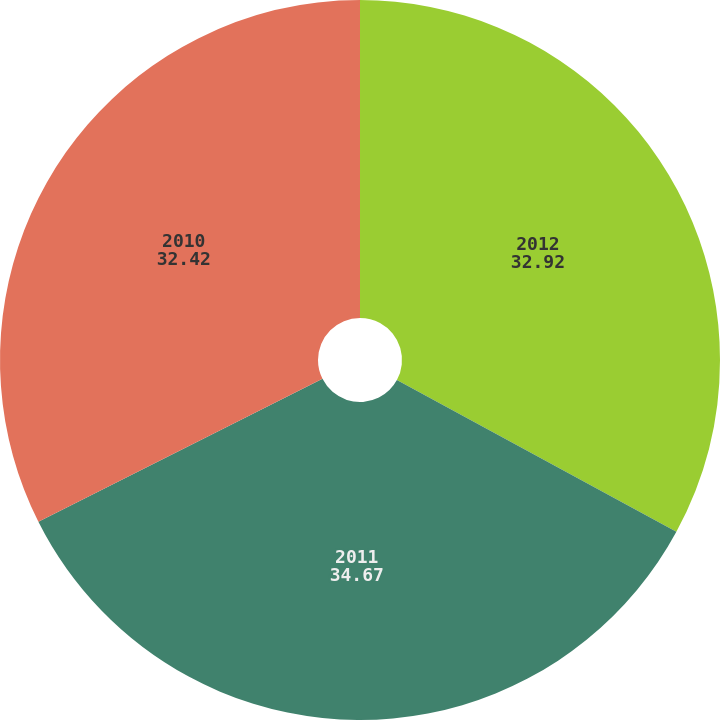Convert chart. <chart><loc_0><loc_0><loc_500><loc_500><pie_chart><fcel>2012<fcel>2011<fcel>2010<nl><fcel>32.92%<fcel>34.67%<fcel>32.42%<nl></chart> 